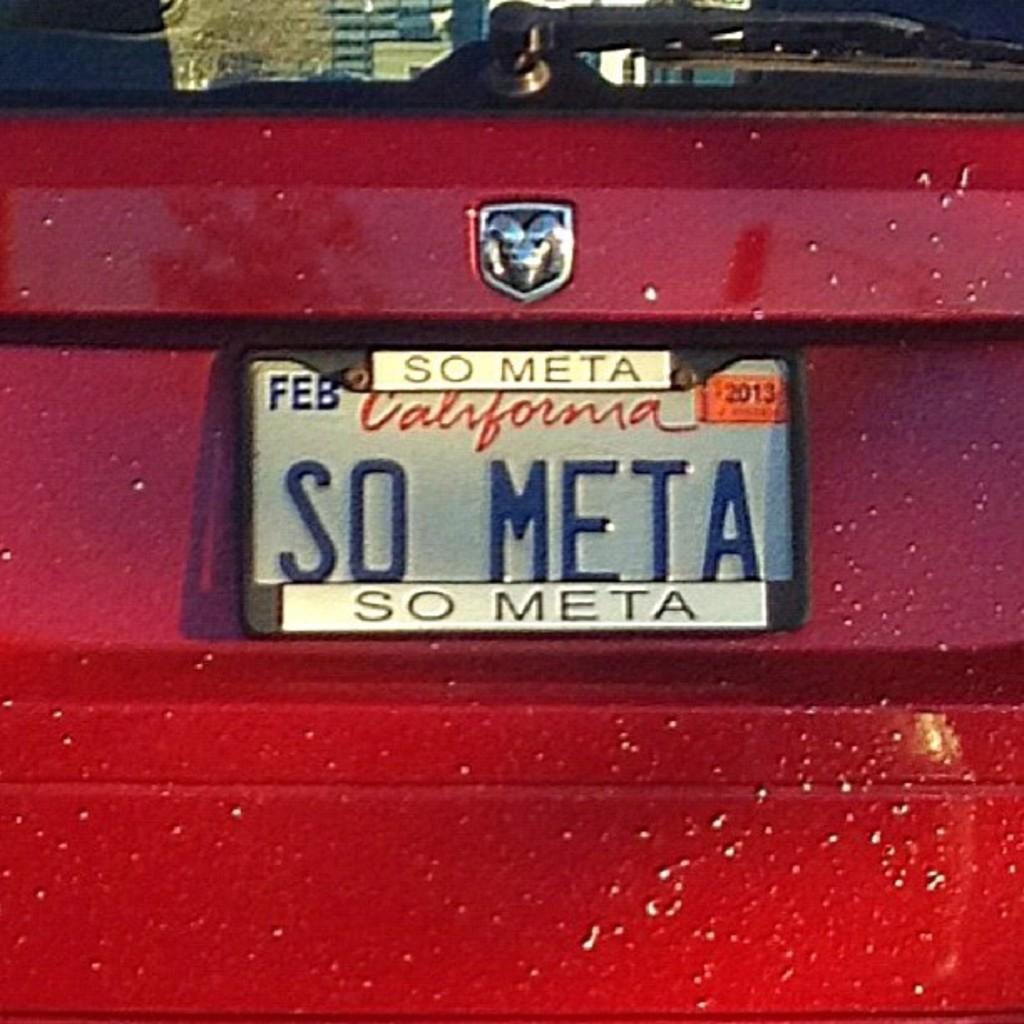Please provide a concise description of this image. In this picture we can observe a car which is in red color. There is a registration plate on which we can observe some text. We can observe a wiper on the back windshield. 